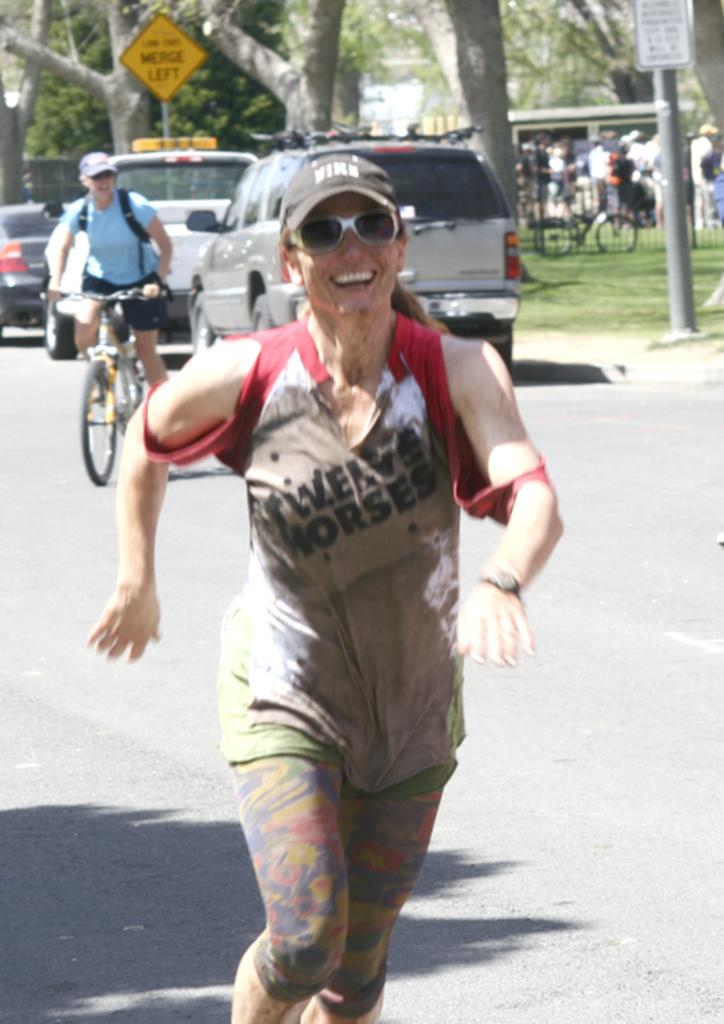What is the woman in the center of the image doing? The woman is running in the center of the image. What is the expression on the woman's face? The woman is smiling. What can be seen in the background of the image? There is a sign board, vehicles, trees, grass, a pole, and persons standing in the background of the image. What type of oatmeal is the woman eating while running in the image? There is no oatmeal present in the image; the woman is running and smiling. Can you see any mittens on the persons standing in the background of the image? There is no mention of mittens in the image; only the woman running and the elements in the background are described. 